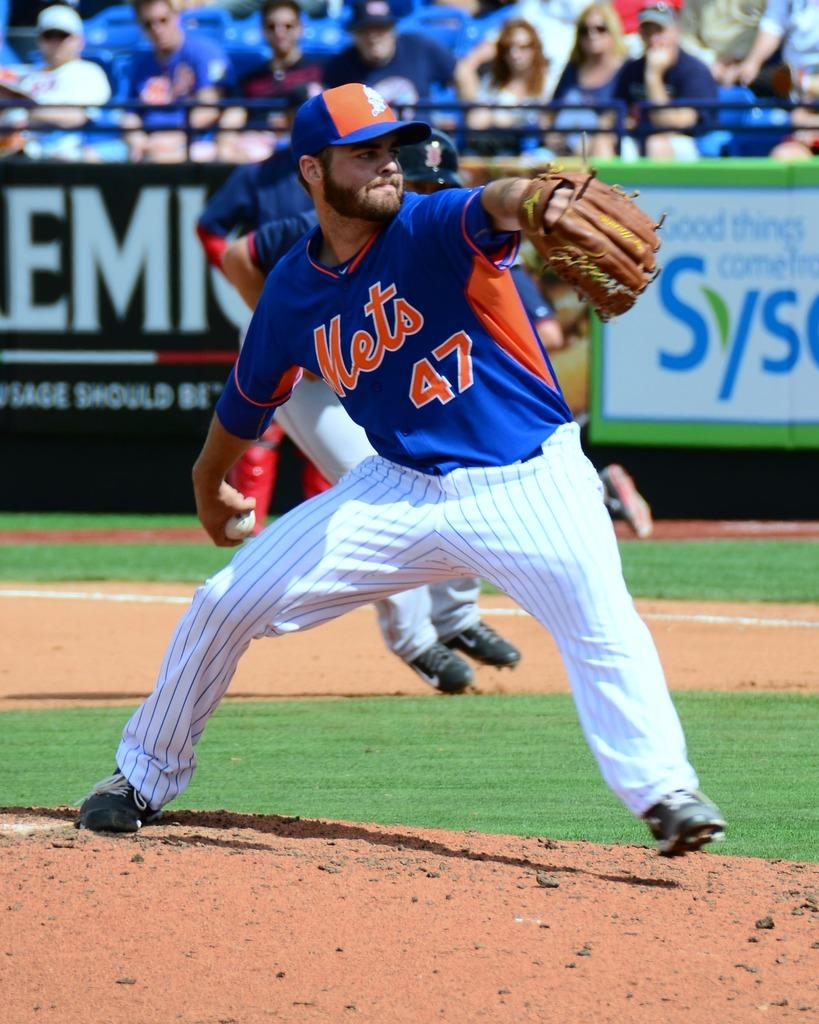<image>
Share a concise interpretation of the image provided. a mets baseball player with the number 47 on his jersey 